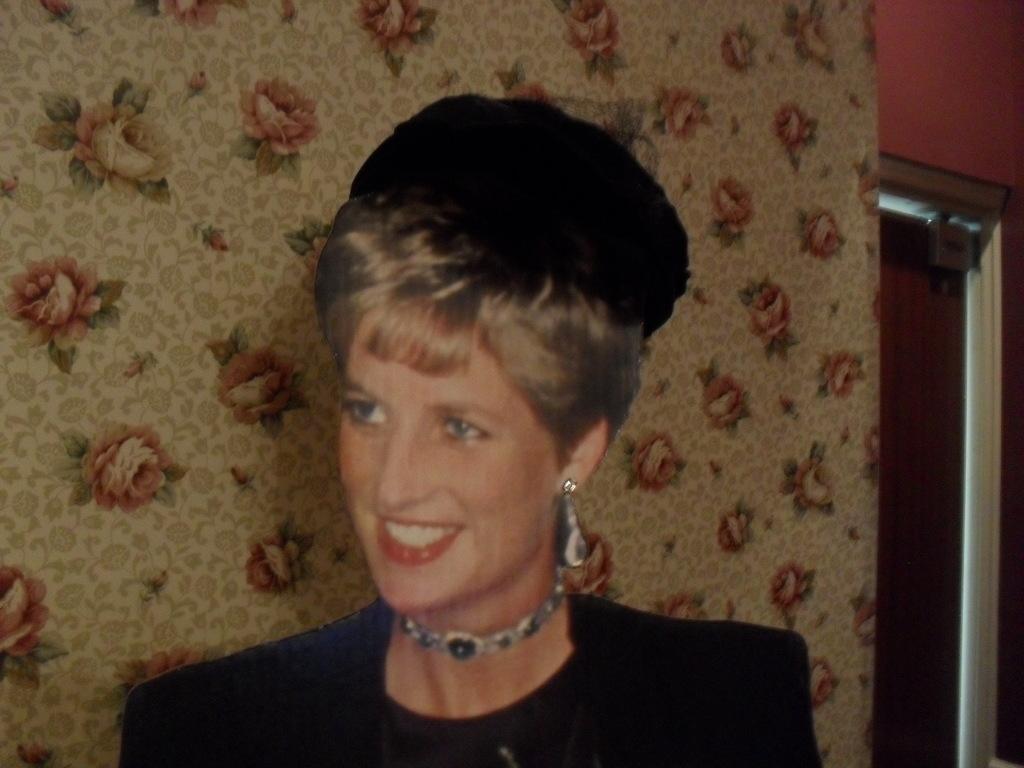Describe this image in one or two sentences. This is a picture of a woman with a smile on her face. 